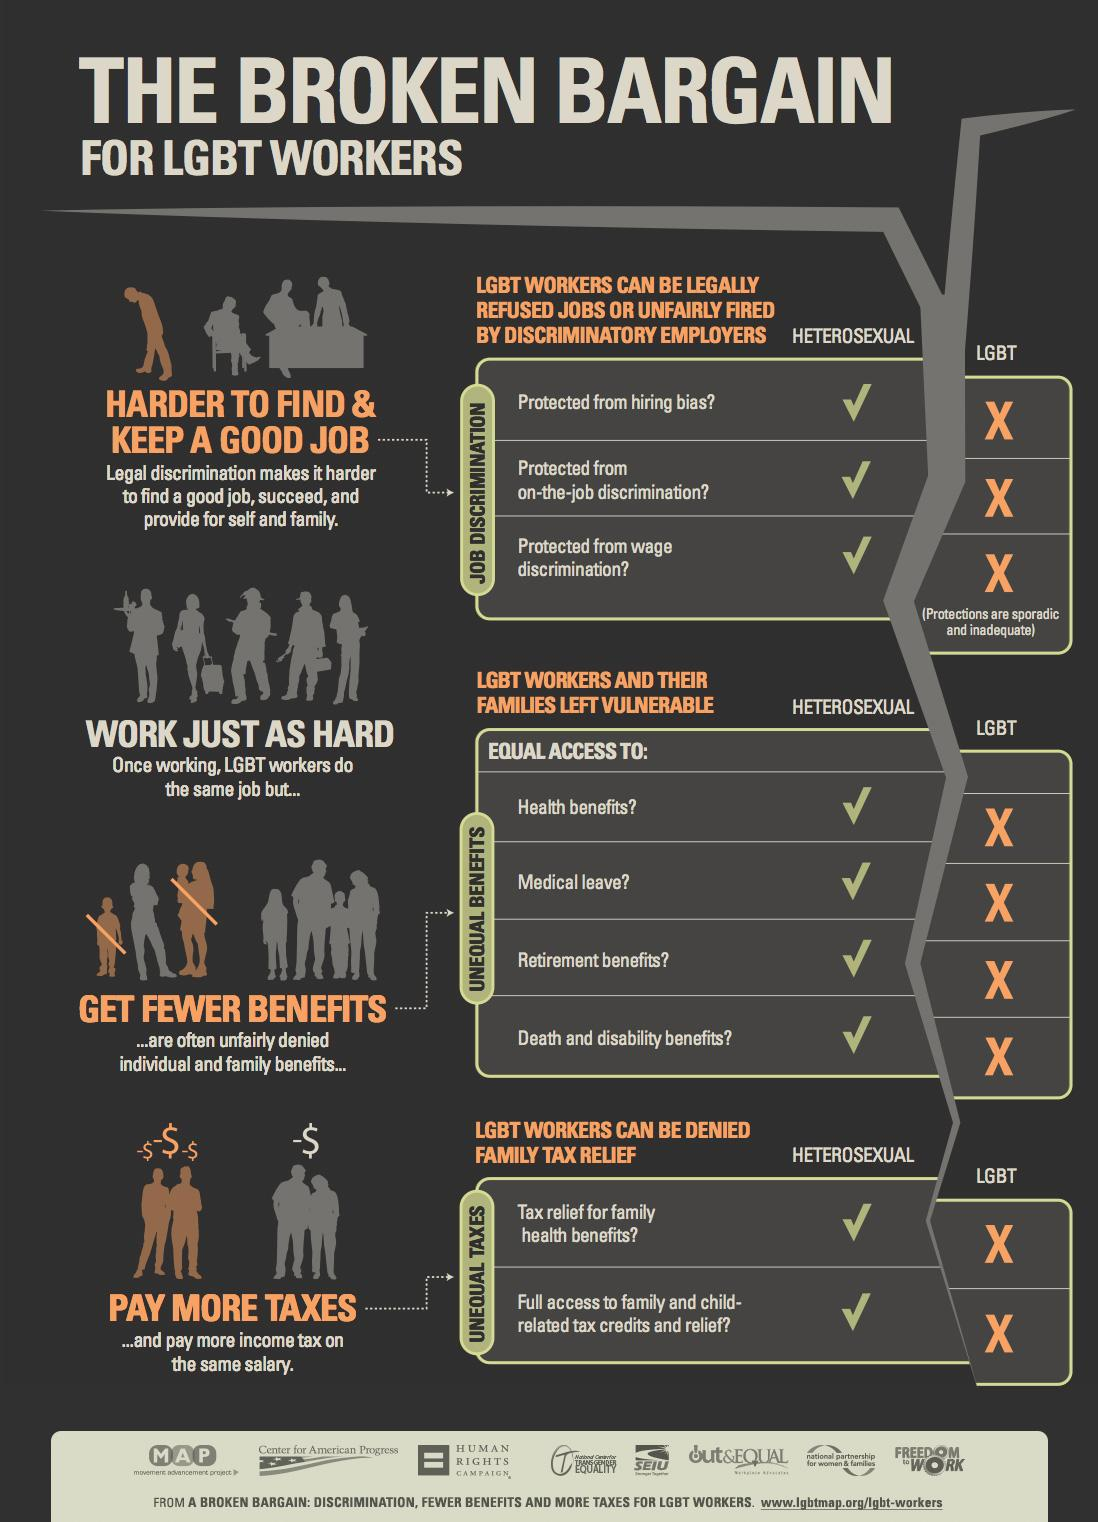Point out several critical features in this image. It is necessary for members of the LGBT community to pay higher taxes. Workers who identify as LGBT are not protected from wage discrimination. LGBT individuals face significant barriers in securing employment due to legal discrimination. Heterosexual workers are protected from hiring bias. LGBT workers are often denied access to health benefits. 